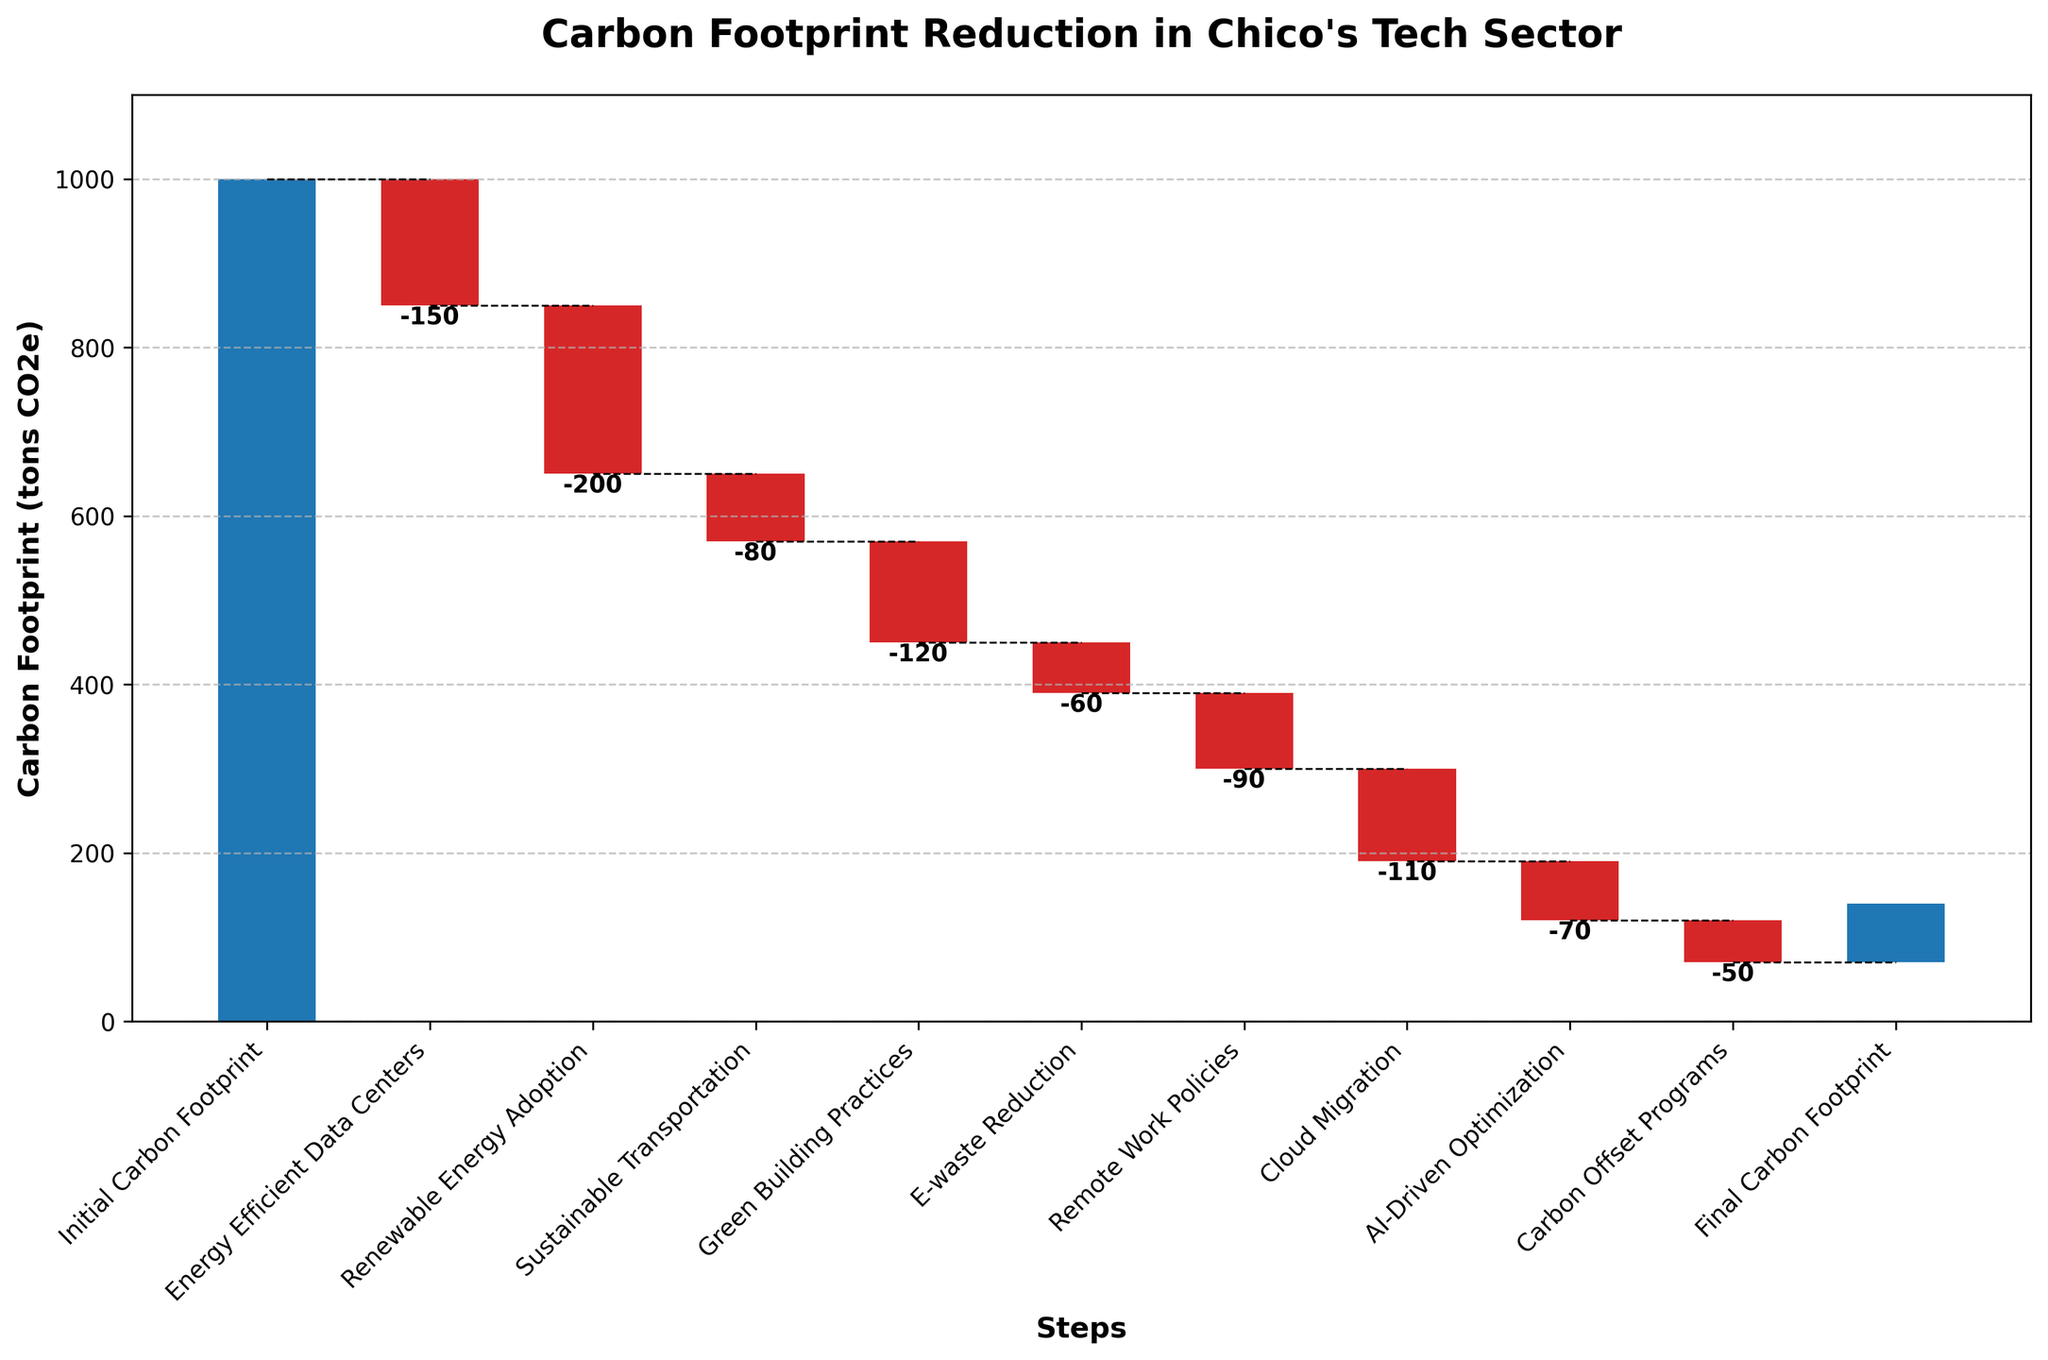What is the initial carbon footprint value? The initial carbon footprint is provided as the first category on the x-axis of the plot.
Answer: 1000 How much reduction is achieved by energy-efficient data centers? The reduction is shown as a negative value in the waterfall chart for the "Energy Efficient Data Centers" category.
Answer: -150 What is Chico's tech sector's final carbon footprint after all reduction efforts? The final carbon footprint is given as the last category on the x-axis of the plot.
Answer: 70 Which category leads to the highest reduction in the carbon footprint? By examining the negative values in the waterfall chart, look for the category with the largest absolute value.
Answer: Renewable Energy Adoption Are there any categories that increase the carbon footprint instead of reducing it? Look for positive bars in the waterfall chart.
Answer: No How many categories are depicted in the chart excluding the initial and final carbon footprint? Count the number of categories between the initial and final carbon footprint on the x-axis.
Answer: 8 In terms of reduction, which category has the smallest impact and what is its value? Identify the category with the smallest negative value in the waterfall chart.
Answer: Carbon Offset Programs, -50 